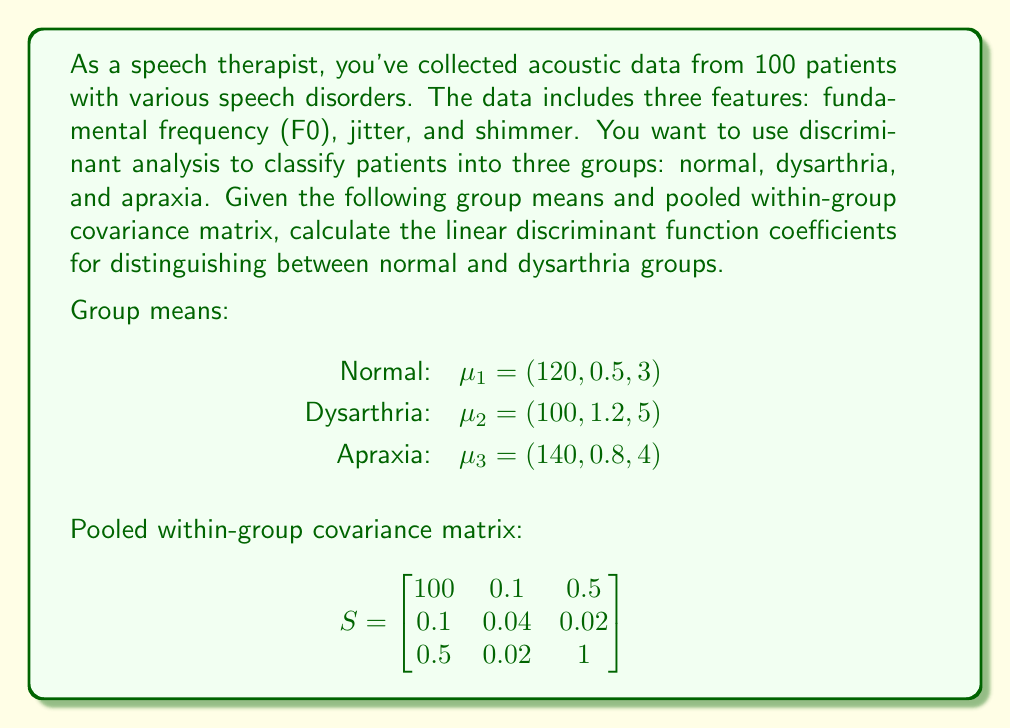Can you solve this math problem? To solve this problem, we'll follow these steps:

1. Recall the formula for linear discriminant function coefficients:
   $$a = S^{-1}(\mu_1 - \mu_2)$$
   where $S^{-1}$ is the inverse of the pooled within-group covariance matrix, and $\mu_1$ and $\mu_2$ are the group means.

2. Calculate the difference between group means:
   $$\mu_1 - \mu_2 = (120, 0.5, 3) - (100, 1.2, 5) = (20, -0.7, -2)$$

3. Calculate the inverse of the pooled within-group covariance matrix:
   $$S^{-1} = \begin{bmatrix}
   0.0100267 & -0.0250668 & -0.0050134 \\
   -0.0250668 & 25.1338 & -0.5033445 \\
   -0.0050134 & -0.5033445 & 1.00602
   \end{bmatrix}$$

4. Multiply $S^{-1}$ by $(\mu_1 - \mu_2)$:
   $$a = S^{-1}(\mu_1 - \mu_2) = \begin{bmatrix}
   0.0100267 & -0.0250668 & -0.0050134 \\
   -0.0250668 & 25.1338 & -0.5033445 \\
   -0.0050134 & -0.5033445 & 1.00602
   \end{bmatrix} \begin{bmatrix}
   20 \\
   -0.7 \\
   -2
   \end{bmatrix}$$

5. Perform the matrix multiplication:
   $$a = \begin{bmatrix}
   0.0100267 \times 20 + (-0.0250668) \times (-0.7) + (-0.0050134) \times (-2) \\
   (-0.0250668) \times 20 + 25.1338 \times (-0.7) + (-0.5033445) \times (-2) \\
   (-0.0050134) \times 20 + (-0.5033445) \times (-0.7) + 1.00602 \times (-2)
   \end{bmatrix}$$

6. Simplify the result:
   $$a = \begin{bmatrix}
   0.2205 \\
   -17.5937 \\
   -1.9014
   \end{bmatrix}$$

These coefficients represent the weights for each acoustic feature (F0, jitter, and shimmer) in the linear discriminant function for distinguishing between normal and dysarthria groups.
Answer: The linear discriminant function coefficients for distinguishing between normal and dysarthria groups are:

$$a = \begin{bmatrix}
0.2205 \\
-17.5937 \\
-1.9014
\end{bmatrix}$$ 